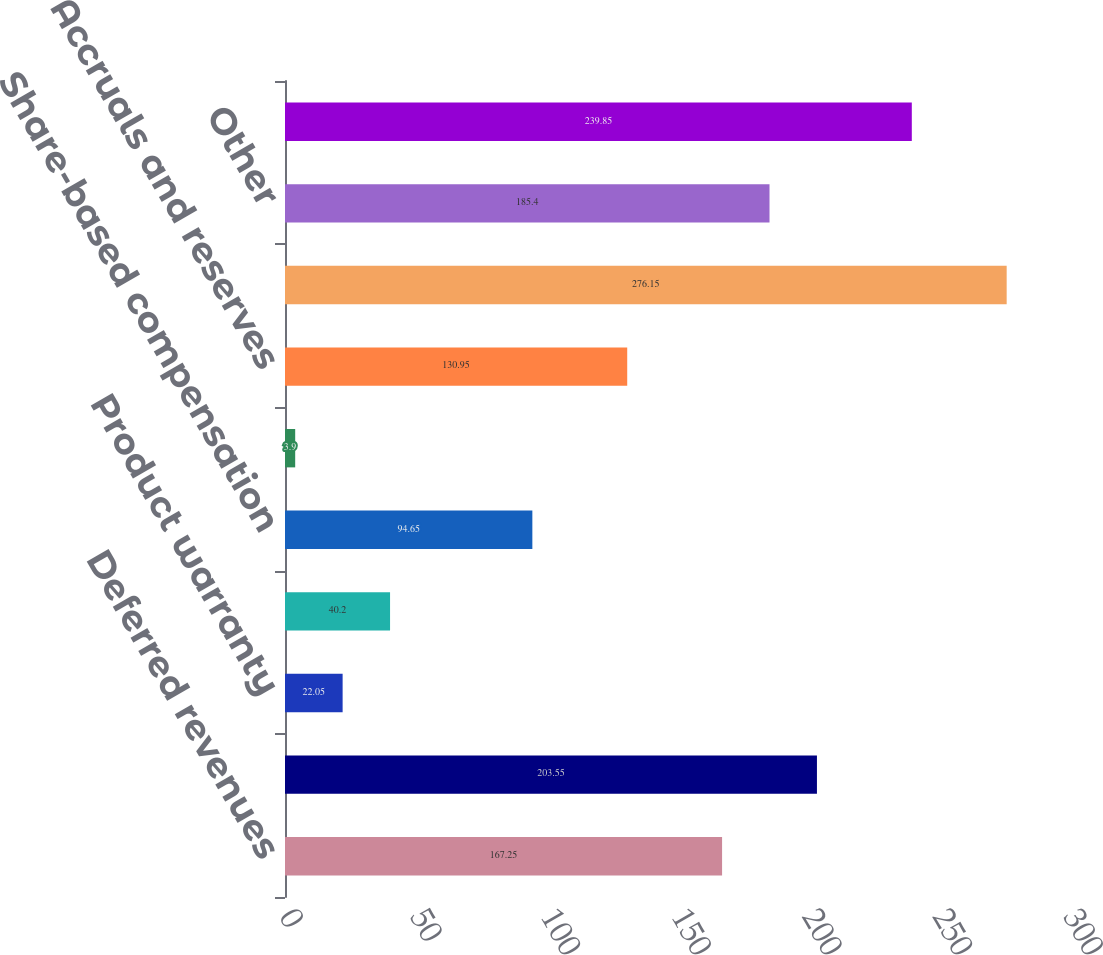<chart> <loc_0><loc_0><loc_500><loc_500><bar_chart><fcel>Deferred revenues<fcel>Deferred compensation<fcel>Product warranty<fcel>Inventory adjustments<fcel>Share-based compensation<fcel>Environmental reserve<fcel>Accruals and reserves<fcel>Net operating loss<fcel>Other<fcel>Valuation allowance<nl><fcel>167.25<fcel>203.55<fcel>22.05<fcel>40.2<fcel>94.65<fcel>3.9<fcel>130.95<fcel>276.15<fcel>185.4<fcel>239.85<nl></chart> 